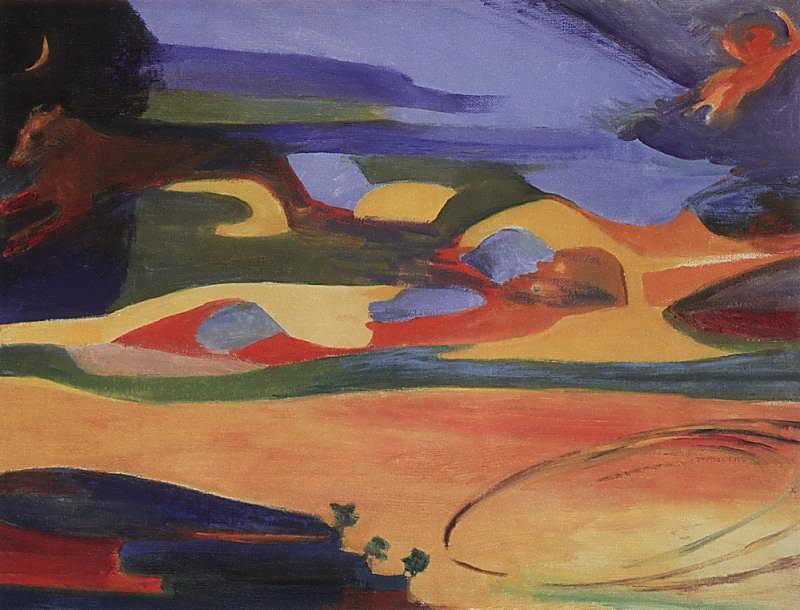Is there a story behind this painting? The painting seems to weave a tale of nature and its myriad forms, with rolling hills and serene bodies of water under a vibrant sky. The hues blend together to create an almost mythical landscape, inviting viewers to immerse themselves in its abstract beauty. The presence of what appears to be a leaping animal in the top left corner adds a dynamic element to the scene, suggesting movement and perhaps a hidden narrative about the natural world's vitality. What emotions do you think the artist wanted to convey? The artist likely intended to evoke a sense of wonder and tranquility. The harmonious blend of colors, along with the fluidity of the brushstrokes, suggests a serene landscape that inspires contemplation. The choice of vivid colors might also indicate an underlying enthusiasm and reverence for nature. Can you describe what you think the animals or figures in the painting represent? The leaping animal in the top left corner could symbolize freedom and the unrestrained energy of the natural world. Its ethereal form blends seamlessly with the abstract background, suggesting that despite the chaotic beauty of nature, everything is interconnected. The faint figures in the sky could be interpreted as spirits or guardians of the landscape, adding a mystical dimension to the painting. 